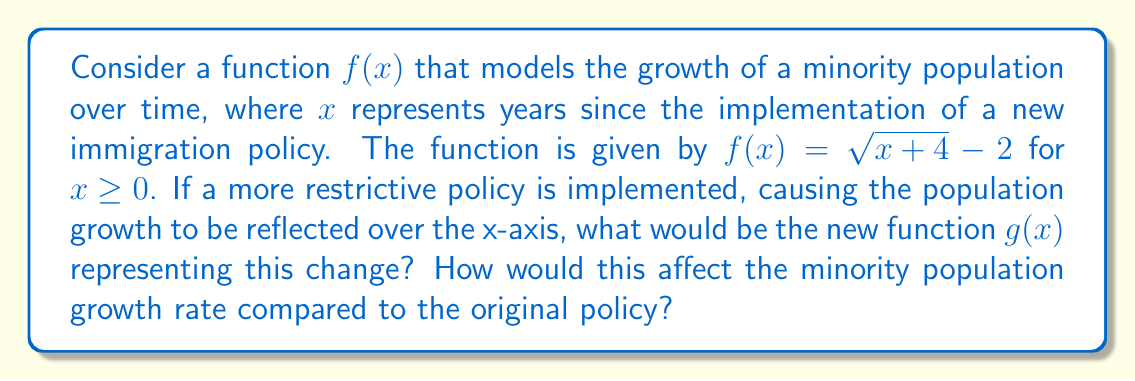Can you answer this question? 1) To reflect a function over the x-axis, we multiply the entire function by -1. So, $g(x) = -f(x)$.

2) Starting with $f(x) = \sqrt{x+4} - 2$, we get:
   $g(x) = -(\sqrt{x+4} - 2)$

3) Simplifying:
   $g(x) = -\sqrt{x+4} + 2$

4) To understand the effect on population growth:
   - $f(x)$ starts at -2 when $x=0$ and increases as $x$ increases.
   - $g(x)$ starts at 2 when $x=0$ and decreases as $x$ increases.

5) The original function $f(x)$ represents a growing population, while the new function $g(x)$ represents a shrinking population.

6) The rate of change (derivative) of $f(x)$ is positive, while the rate of change of $g(x)$ is negative, indicating opposite growth patterns.

7) This reflection represents a significant change in population dynamics, from growth under the original policy to decline under the more restrictive policy.
Answer: $g(x) = -\sqrt{x+4} + 2$; population declines instead of grows 